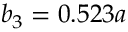Convert formula to latex. <formula><loc_0><loc_0><loc_500><loc_500>b _ { 3 } = 0 . 5 2 3 a</formula> 